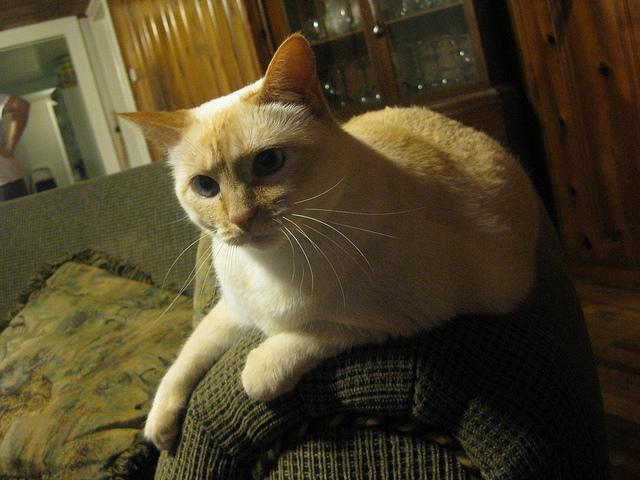How many cats are there?
Concise answer only. 1. Is the window open?
Keep it brief. No. What kind of cat is it?
Be succinct. White. What is the cat laying on?
Concise answer only. Couch. Is the cat sleeping?
Be succinct. No. 